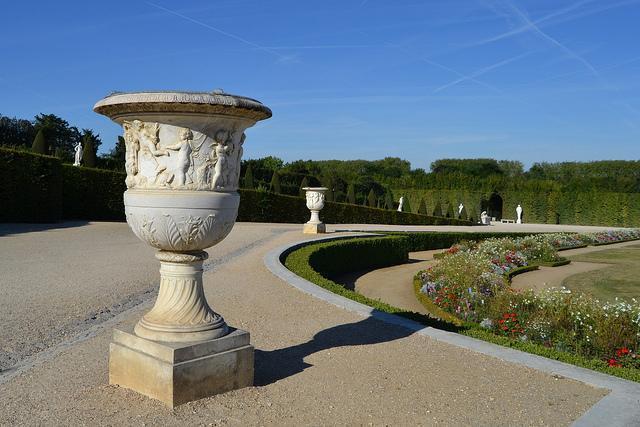How many people are holding microphones?
Give a very brief answer. 0. 